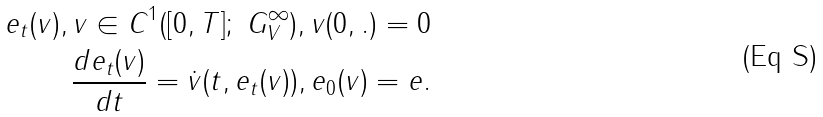<formula> <loc_0><loc_0><loc_500><loc_500>e _ { t } ( v ) , v \in C ^ { 1 } ( [ 0 , T ] ; \ G _ { V } ^ { \infty } ) , v ( 0 , . ) = 0 \\ \frac { d e _ { t } ( v ) } { d t } = \dot { v } ( t , e _ { t } ( v ) ) , e _ { 0 } ( v ) = e .</formula> 